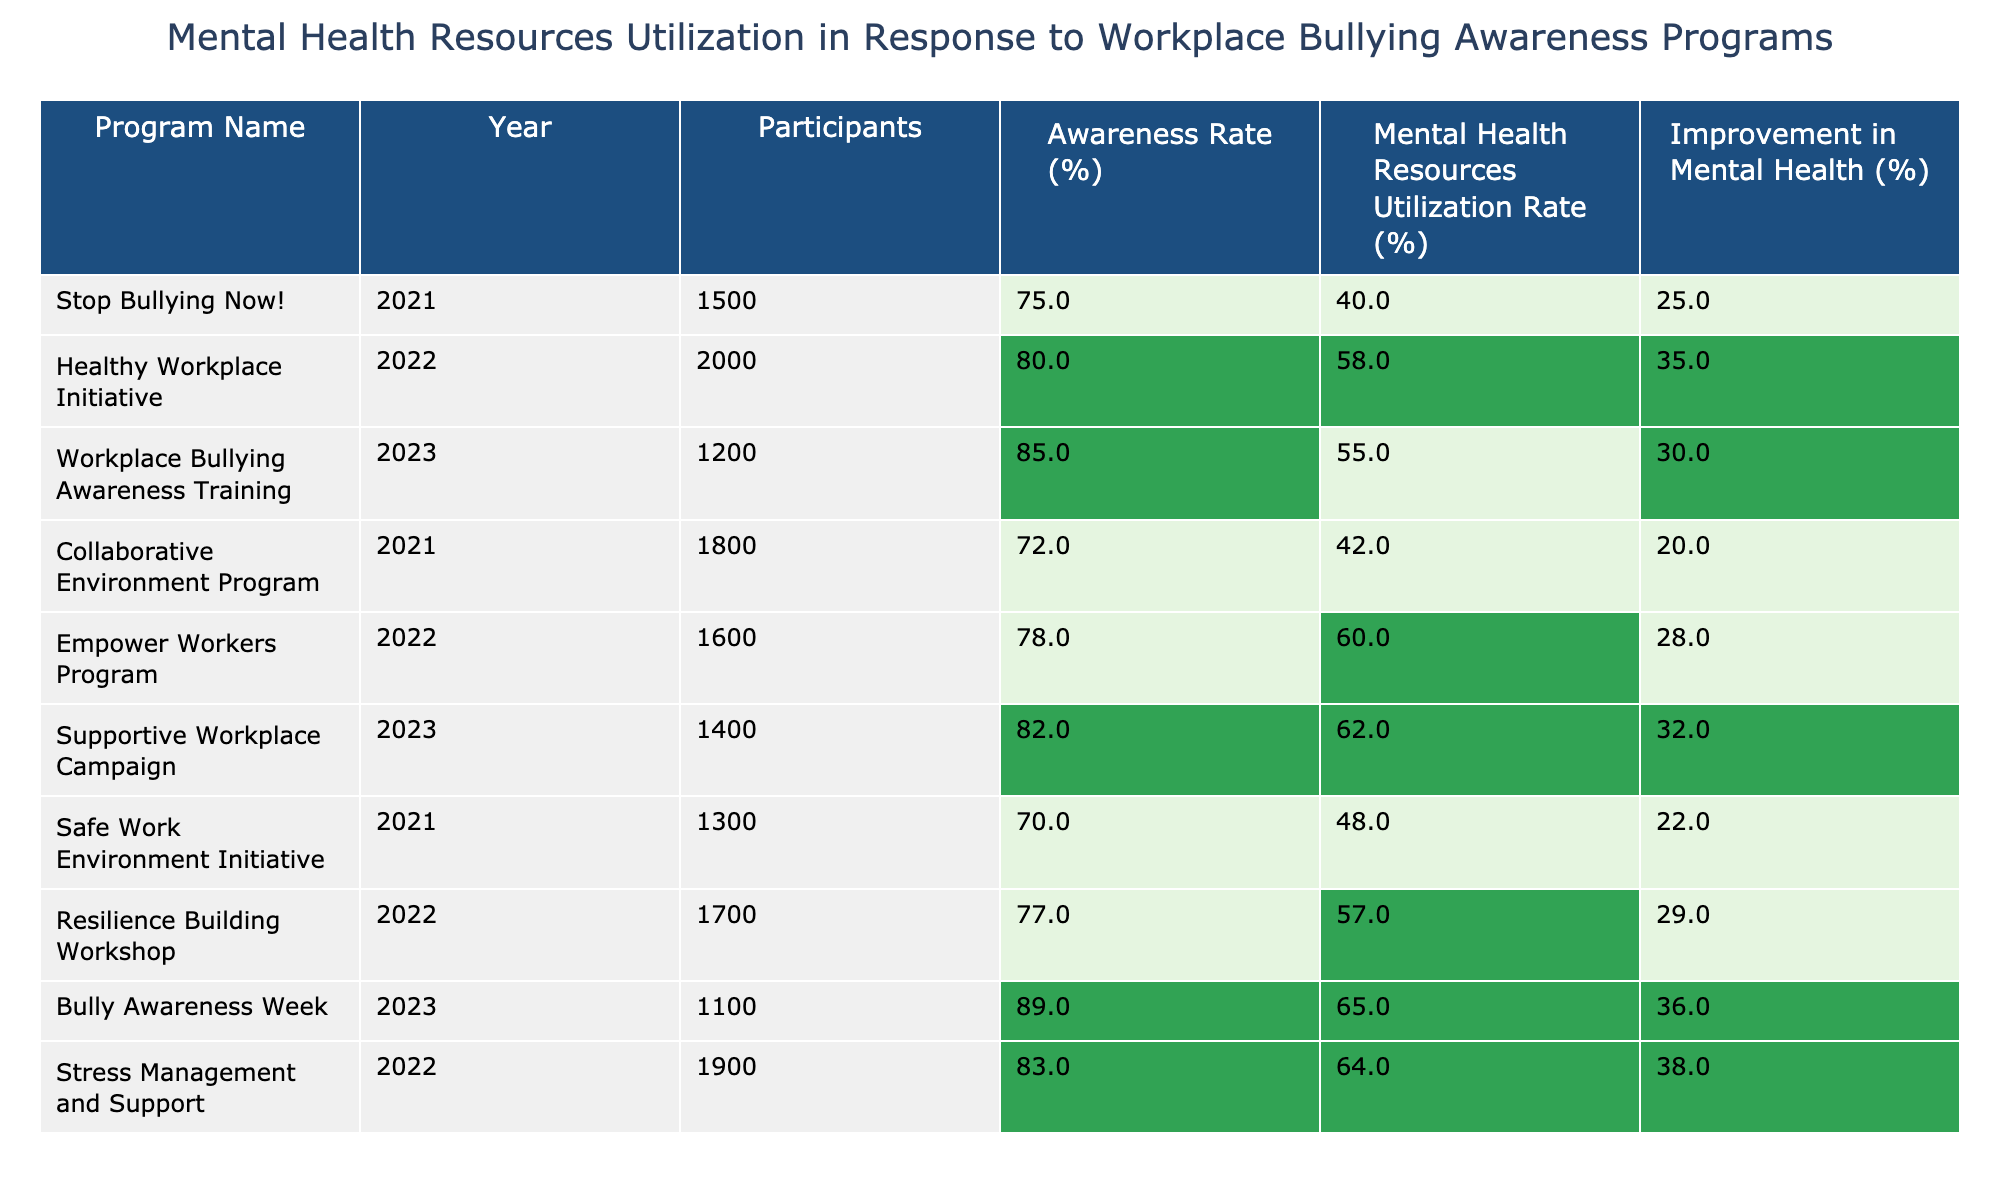What is the highest Mental Health Resources Utilization Rate among the programs listed? The table shows the Mental Health Resources Utilization Rates for all programs. The highest value is 65% for the "Bully Awareness Week" program in 2023.
Answer: 65% Which program had the lowest Awareness Rate? By examining the Awareness Rates, the program "Safe Work Environment Initiative" has the lowest rate at 70%.
Answer: 70% What was the average Improvement in Mental Health across all programs? To find the average, I will sum all Improvement in Mental Health values: (25 + 35 + 30 + 20 + 28 + 32 + 22 + 29 + 36 + 38) =  365. Dividing by the number of programs (10) gives 365/10 = 36.5%.
Answer: 36.5% Did the "Healthy Workplace Initiative" have a higher Mental Health Resources Utilization Rate than the "Stop Bullying Now!" program? The "Healthy Workplace Initiative" has a utilization rate of 58%, while the "Stop Bullying Now!" program has 40%. Since 58% is greater than 40%, the answer is yes.
Answer: Yes What is the difference in Mental Health Resources Utilization Rate between the "Supportive Workplace Campaign" and the "Resilience Building Workshop"? The "Supportive Workplace Campaign" has a utilization rate of 62%, and the "Resilience Building Workshop" has 57%. The difference is 62 - 57 = 5%.
Answer: 5% Which year saw the highest number of participants across all programs? Looking at the number of participants by year, 2022 had the highest at 2000 participants for the "Healthy Workplace Initiative."
Answer: 2000 What is the improvement percentage for the program with the second lowest Awareness Rate? The second lowest Awareness Rate is for the "Collaborative Environment Program" at 72%, which has an Improvement in Mental Health of 20%.
Answer: 20% Did more than 50% of participants utilize mental health resources in the "Stress Management and Support" program? The "Stress Management and Support" program has a utilization rate of 64%, which is greater than 50%.
Answer: Yes What is the average Awareness Rate for all programs listed? The Awareness Rates are summed as (75 + 80 + 85 + 72 + 78 + 82 + 70 + 77 + 89 + 83) =  800. Then, dividing by 10 gives an average of 800/10 = 80%.
Answer: 80% Which two programs had the highest and second highest Improvement in Mental Health percentages, respectively? Scanning through the Improvement in Mental Health values, the highest is 38% from "Stress Management and Support," and the second highest is 36% from "Bully Awareness Week."
Answer: 38% and 36% 